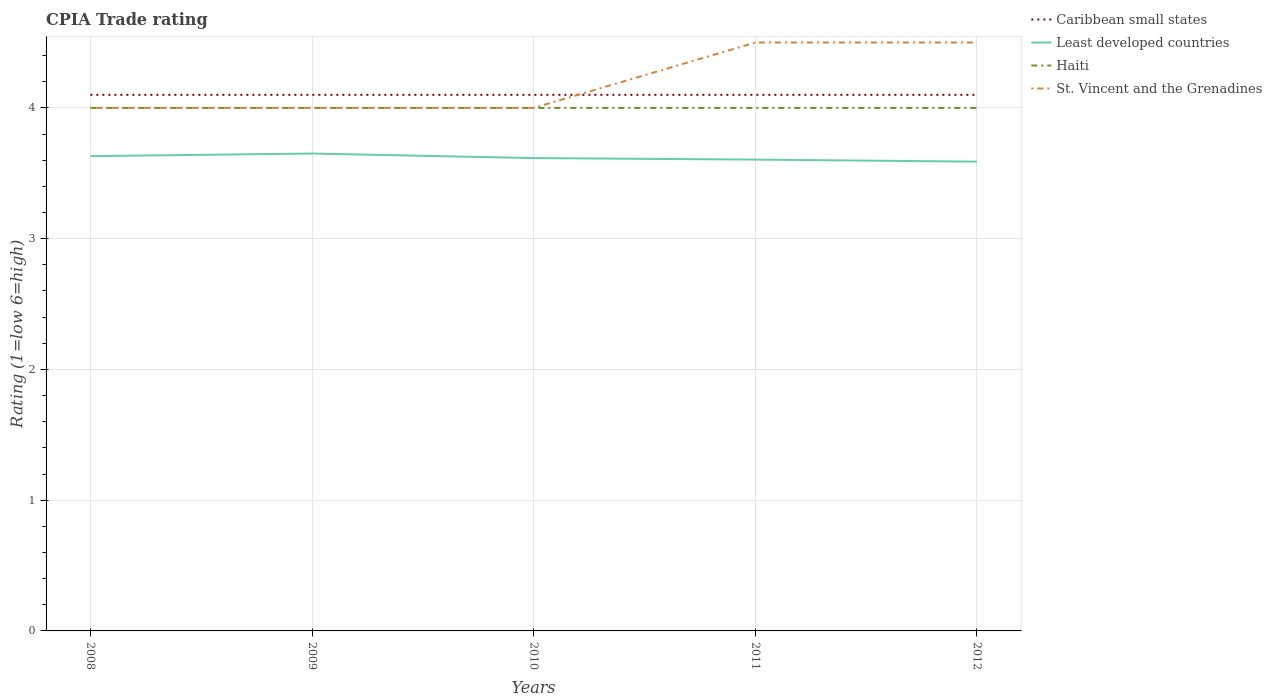How many different coloured lines are there?
Give a very brief answer. 4. Does the line corresponding to Caribbean small states intersect with the line corresponding to Haiti?
Your response must be concise. No. Is the number of lines equal to the number of legend labels?
Offer a terse response. Yes. Across all years, what is the maximum CPIA rating in St. Vincent and the Grenadines?
Offer a very short reply. 4. What is the difference between the highest and the second highest CPIA rating in Haiti?
Make the answer very short. 0. What is the difference between the highest and the lowest CPIA rating in Haiti?
Your answer should be very brief. 0. Does the graph contain any zero values?
Provide a short and direct response. No. Does the graph contain grids?
Your answer should be very brief. Yes. How many legend labels are there?
Provide a succinct answer. 4. How are the legend labels stacked?
Provide a short and direct response. Vertical. What is the title of the graph?
Make the answer very short. CPIA Trade rating. What is the label or title of the X-axis?
Provide a succinct answer. Years. What is the label or title of the Y-axis?
Give a very brief answer. Rating (1=low 6=high). What is the Rating (1=low 6=high) of Least developed countries in 2008?
Provide a succinct answer. 3.63. What is the Rating (1=low 6=high) in St. Vincent and the Grenadines in 2008?
Provide a short and direct response. 4. What is the Rating (1=low 6=high) of Caribbean small states in 2009?
Your answer should be very brief. 4.1. What is the Rating (1=low 6=high) in Least developed countries in 2009?
Give a very brief answer. 3.65. What is the Rating (1=low 6=high) in St. Vincent and the Grenadines in 2009?
Your answer should be very brief. 4. What is the Rating (1=low 6=high) in Caribbean small states in 2010?
Offer a very short reply. 4.1. What is the Rating (1=low 6=high) in Least developed countries in 2010?
Offer a very short reply. 3.62. What is the Rating (1=low 6=high) in Haiti in 2010?
Your answer should be compact. 4. What is the Rating (1=low 6=high) in St. Vincent and the Grenadines in 2010?
Your answer should be very brief. 4. What is the Rating (1=low 6=high) of Least developed countries in 2011?
Your answer should be very brief. 3.6. What is the Rating (1=low 6=high) of St. Vincent and the Grenadines in 2011?
Your response must be concise. 4.5. What is the Rating (1=low 6=high) in Caribbean small states in 2012?
Keep it short and to the point. 4.1. What is the Rating (1=low 6=high) in Least developed countries in 2012?
Keep it short and to the point. 3.59. What is the Rating (1=low 6=high) in St. Vincent and the Grenadines in 2012?
Your response must be concise. 4.5. Across all years, what is the maximum Rating (1=low 6=high) of Least developed countries?
Make the answer very short. 3.65. Across all years, what is the maximum Rating (1=low 6=high) in St. Vincent and the Grenadines?
Make the answer very short. 4.5. Across all years, what is the minimum Rating (1=low 6=high) of Least developed countries?
Ensure brevity in your answer.  3.59. What is the total Rating (1=low 6=high) in Least developed countries in the graph?
Your answer should be very brief. 18.09. What is the difference between the Rating (1=low 6=high) of Least developed countries in 2008 and that in 2009?
Give a very brief answer. -0.02. What is the difference between the Rating (1=low 6=high) in Haiti in 2008 and that in 2009?
Give a very brief answer. 0. What is the difference between the Rating (1=low 6=high) in Caribbean small states in 2008 and that in 2010?
Your response must be concise. 0. What is the difference between the Rating (1=low 6=high) of Least developed countries in 2008 and that in 2010?
Offer a very short reply. 0.01. What is the difference between the Rating (1=low 6=high) in Haiti in 2008 and that in 2010?
Offer a very short reply. 0. What is the difference between the Rating (1=low 6=high) in St. Vincent and the Grenadines in 2008 and that in 2010?
Offer a very short reply. 0. What is the difference between the Rating (1=low 6=high) in Least developed countries in 2008 and that in 2011?
Ensure brevity in your answer.  0.03. What is the difference between the Rating (1=low 6=high) of Haiti in 2008 and that in 2011?
Offer a terse response. 0. What is the difference between the Rating (1=low 6=high) of Least developed countries in 2008 and that in 2012?
Your answer should be compact. 0.04. What is the difference between the Rating (1=low 6=high) of Caribbean small states in 2009 and that in 2010?
Make the answer very short. 0. What is the difference between the Rating (1=low 6=high) in Least developed countries in 2009 and that in 2010?
Offer a terse response. 0.03. What is the difference between the Rating (1=low 6=high) in Haiti in 2009 and that in 2010?
Your answer should be compact. 0. What is the difference between the Rating (1=low 6=high) in St. Vincent and the Grenadines in 2009 and that in 2010?
Make the answer very short. 0. What is the difference between the Rating (1=low 6=high) of Least developed countries in 2009 and that in 2011?
Offer a terse response. 0.05. What is the difference between the Rating (1=low 6=high) in Least developed countries in 2009 and that in 2012?
Give a very brief answer. 0.06. What is the difference between the Rating (1=low 6=high) of Caribbean small states in 2010 and that in 2011?
Provide a succinct answer. 0. What is the difference between the Rating (1=low 6=high) in Least developed countries in 2010 and that in 2011?
Give a very brief answer. 0.01. What is the difference between the Rating (1=low 6=high) in Haiti in 2010 and that in 2011?
Your answer should be very brief. 0. What is the difference between the Rating (1=low 6=high) of Caribbean small states in 2010 and that in 2012?
Offer a terse response. 0. What is the difference between the Rating (1=low 6=high) of Least developed countries in 2010 and that in 2012?
Offer a terse response. 0.03. What is the difference between the Rating (1=low 6=high) in Haiti in 2010 and that in 2012?
Your answer should be very brief. 0. What is the difference between the Rating (1=low 6=high) in Least developed countries in 2011 and that in 2012?
Ensure brevity in your answer.  0.02. What is the difference between the Rating (1=low 6=high) of Haiti in 2011 and that in 2012?
Make the answer very short. 0. What is the difference between the Rating (1=low 6=high) of Caribbean small states in 2008 and the Rating (1=low 6=high) of Least developed countries in 2009?
Your answer should be compact. 0.45. What is the difference between the Rating (1=low 6=high) of Caribbean small states in 2008 and the Rating (1=low 6=high) of Haiti in 2009?
Give a very brief answer. 0.1. What is the difference between the Rating (1=low 6=high) of Least developed countries in 2008 and the Rating (1=low 6=high) of Haiti in 2009?
Provide a succinct answer. -0.37. What is the difference between the Rating (1=low 6=high) of Least developed countries in 2008 and the Rating (1=low 6=high) of St. Vincent and the Grenadines in 2009?
Ensure brevity in your answer.  -0.37. What is the difference between the Rating (1=low 6=high) in Haiti in 2008 and the Rating (1=low 6=high) in St. Vincent and the Grenadines in 2009?
Your response must be concise. 0. What is the difference between the Rating (1=low 6=high) of Caribbean small states in 2008 and the Rating (1=low 6=high) of Least developed countries in 2010?
Your answer should be compact. 0.48. What is the difference between the Rating (1=low 6=high) in Caribbean small states in 2008 and the Rating (1=low 6=high) in Haiti in 2010?
Make the answer very short. 0.1. What is the difference between the Rating (1=low 6=high) in Least developed countries in 2008 and the Rating (1=low 6=high) in Haiti in 2010?
Provide a short and direct response. -0.37. What is the difference between the Rating (1=low 6=high) of Least developed countries in 2008 and the Rating (1=low 6=high) of St. Vincent and the Grenadines in 2010?
Your response must be concise. -0.37. What is the difference between the Rating (1=low 6=high) in Caribbean small states in 2008 and the Rating (1=low 6=high) in Least developed countries in 2011?
Your answer should be compact. 0.5. What is the difference between the Rating (1=low 6=high) of Least developed countries in 2008 and the Rating (1=low 6=high) of Haiti in 2011?
Your answer should be compact. -0.37. What is the difference between the Rating (1=low 6=high) of Least developed countries in 2008 and the Rating (1=low 6=high) of St. Vincent and the Grenadines in 2011?
Offer a very short reply. -0.87. What is the difference between the Rating (1=low 6=high) of Caribbean small states in 2008 and the Rating (1=low 6=high) of Least developed countries in 2012?
Offer a terse response. 0.51. What is the difference between the Rating (1=low 6=high) of Caribbean small states in 2008 and the Rating (1=low 6=high) of Haiti in 2012?
Keep it short and to the point. 0.1. What is the difference between the Rating (1=low 6=high) in Caribbean small states in 2008 and the Rating (1=low 6=high) in St. Vincent and the Grenadines in 2012?
Ensure brevity in your answer.  -0.4. What is the difference between the Rating (1=low 6=high) in Least developed countries in 2008 and the Rating (1=low 6=high) in Haiti in 2012?
Your response must be concise. -0.37. What is the difference between the Rating (1=low 6=high) of Least developed countries in 2008 and the Rating (1=low 6=high) of St. Vincent and the Grenadines in 2012?
Provide a short and direct response. -0.87. What is the difference between the Rating (1=low 6=high) of Haiti in 2008 and the Rating (1=low 6=high) of St. Vincent and the Grenadines in 2012?
Give a very brief answer. -0.5. What is the difference between the Rating (1=low 6=high) of Caribbean small states in 2009 and the Rating (1=low 6=high) of Least developed countries in 2010?
Offer a very short reply. 0.48. What is the difference between the Rating (1=low 6=high) in Caribbean small states in 2009 and the Rating (1=low 6=high) in St. Vincent and the Grenadines in 2010?
Your response must be concise. 0.1. What is the difference between the Rating (1=low 6=high) in Least developed countries in 2009 and the Rating (1=low 6=high) in Haiti in 2010?
Provide a succinct answer. -0.35. What is the difference between the Rating (1=low 6=high) in Least developed countries in 2009 and the Rating (1=low 6=high) in St. Vincent and the Grenadines in 2010?
Provide a succinct answer. -0.35. What is the difference between the Rating (1=low 6=high) in Caribbean small states in 2009 and the Rating (1=low 6=high) in Least developed countries in 2011?
Make the answer very short. 0.5. What is the difference between the Rating (1=low 6=high) in Caribbean small states in 2009 and the Rating (1=low 6=high) in Haiti in 2011?
Your answer should be compact. 0.1. What is the difference between the Rating (1=low 6=high) of Least developed countries in 2009 and the Rating (1=low 6=high) of Haiti in 2011?
Provide a succinct answer. -0.35. What is the difference between the Rating (1=low 6=high) in Least developed countries in 2009 and the Rating (1=low 6=high) in St. Vincent and the Grenadines in 2011?
Offer a very short reply. -0.85. What is the difference between the Rating (1=low 6=high) of Haiti in 2009 and the Rating (1=low 6=high) of St. Vincent and the Grenadines in 2011?
Make the answer very short. -0.5. What is the difference between the Rating (1=low 6=high) of Caribbean small states in 2009 and the Rating (1=low 6=high) of Least developed countries in 2012?
Offer a terse response. 0.51. What is the difference between the Rating (1=low 6=high) in Caribbean small states in 2009 and the Rating (1=low 6=high) in Haiti in 2012?
Your answer should be compact. 0.1. What is the difference between the Rating (1=low 6=high) in Caribbean small states in 2009 and the Rating (1=low 6=high) in St. Vincent and the Grenadines in 2012?
Offer a very short reply. -0.4. What is the difference between the Rating (1=low 6=high) of Least developed countries in 2009 and the Rating (1=low 6=high) of Haiti in 2012?
Your answer should be very brief. -0.35. What is the difference between the Rating (1=low 6=high) in Least developed countries in 2009 and the Rating (1=low 6=high) in St. Vincent and the Grenadines in 2012?
Offer a terse response. -0.85. What is the difference between the Rating (1=low 6=high) of Caribbean small states in 2010 and the Rating (1=low 6=high) of Least developed countries in 2011?
Provide a short and direct response. 0.5. What is the difference between the Rating (1=low 6=high) of Caribbean small states in 2010 and the Rating (1=low 6=high) of Haiti in 2011?
Offer a very short reply. 0.1. What is the difference between the Rating (1=low 6=high) in Caribbean small states in 2010 and the Rating (1=low 6=high) in St. Vincent and the Grenadines in 2011?
Provide a short and direct response. -0.4. What is the difference between the Rating (1=low 6=high) in Least developed countries in 2010 and the Rating (1=low 6=high) in Haiti in 2011?
Provide a succinct answer. -0.38. What is the difference between the Rating (1=low 6=high) in Least developed countries in 2010 and the Rating (1=low 6=high) in St. Vincent and the Grenadines in 2011?
Provide a succinct answer. -0.88. What is the difference between the Rating (1=low 6=high) in Caribbean small states in 2010 and the Rating (1=low 6=high) in Least developed countries in 2012?
Make the answer very short. 0.51. What is the difference between the Rating (1=low 6=high) in Caribbean small states in 2010 and the Rating (1=low 6=high) in Haiti in 2012?
Provide a short and direct response. 0.1. What is the difference between the Rating (1=low 6=high) of Caribbean small states in 2010 and the Rating (1=low 6=high) of St. Vincent and the Grenadines in 2012?
Offer a terse response. -0.4. What is the difference between the Rating (1=low 6=high) of Least developed countries in 2010 and the Rating (1=low 6=high) of Haiti in 2012?
Offer a very short reply. -0.38. What is the difference between the Rating (1=low 6=high) of Least developed countries in 2010 and the Rating (1=low 6=high) of St. Vincent and the Grenadines in 2012?
Make the answer very short. -0.88. What is the difference between the Rating (1=low 6=high) in Caribbean small states in 2011 and the Rating (1=low 6=high) in Least developed countries in 2012?
Your answer should be very brief. 0.51. What is the difference between the Rating (1=low 6=high) of Caribbean small states in 2011 and the Rating (1=low 6=high) of Haiti in 2012?
Provide a succinct answer. 0.1. What is the difference between the Rating (1=low 6=high) of Least developed countries in 2011 and the Rating (1=low 6=high) of Haiti in 2012?
Provide a short and direct response. -0.4. What is the difference between the Rating (1=low 6=high) in Least developed countries in 2011 and the Rating (1=low 6=high) in St. Vincent and the Grenadines in 2012?
Provide a short and direct response. -0.9. What is the average Rating (1=low 6=high) in Least developed countries per year?
Your answer should be compact. 3.62. What is the average Rating (1=low 6=high) in Haiti per year?
Provide a succinct answer. 4. What is the average Rating (1=low 6=high) of St. Vincent and the Grenadines per year?
Keep it short and to the point. 4.2. In the year 2008, what is the difference between the Rating (1=low 6=high) of Caribbean small states and Rating (1=low 6=high) of Least developed countries?
Keep it short and to the point. 0.47. In the year 2008, what is the difference between the Rating (1=low 6=high) in Caribbean small states and Rating (1=low 6=high) in Haiti?
Ensure brevity in your answer.  0.1. In the year 2008, what is the difference between the Rating (1=low 6=high) of Caribbean small states and Rating (1=low 6=high) of St. Vincent and the Grenadines?
Provide a succinct answer. 0.1. In the year 2008, what is the difference between the Rating (1=low 6=high) of Least developed countries and Rating (1=low 6=high) of Haiti?
Your answer should be very brief. -0.37. In the year 2008, what is the difference between the Rating (1=low 6=high) in Least developed countries and Rating (1=low 6=high) in St. Vincent and the Grenadines?
Make the answer very short. -0.37. In the year 2009, what is the difference between the Rating (1=low 6=high) in Caribbean small states and Rating (1=low 6=high) in Least developed countries?
Your answer should be very brief. 0.45. In the year 2009, what is the difference between the Rating (1=low 6=high) of Caribbean small states and Rating (1=low 6=high) of Haiti?
Offer a very short reply. 0.1. In the year 2009, what is the difference between the Rating (1=low 6=high) of Least developed countries and Rating (1=low 6=high) of Haiti?
Your answer should be compact. -0.35. In the year 2009, what is the difference between the Rating (1=low 6=high) in Least developed countries and Rating (1=low 6=high) in St. Vincent and the Grenadines?
Your response must be concise. -0.35. In the year 2010, what is the difference between the Rating (1=low 6=high) of Caribbean small states and Rating (1=low 6=high) of Least developed countries?
Your response must be concise. 0.48. In the year 2010, what is the difference between the Rating (1=low 6=high) in Caribbean small states and Rating (1=low 6=high) in St. Vincent and the Grenadines?
Offer a terse response. 0.1. In the year 2010, what is the difference between the Rating (1=low 6=high) in Least developed countries and Rating (1=low 6=high) in Haiti?
Give a very brief answer. -0.38. In the year 2010, what is the difference between the Rating (1=low 6=high) of Least developed countries and Rating (1=low 6=high) of St. Vincent and the Grenadines?
Your answer should be compact. -0.38. In the year 2010, what is the difference between the Rating (1=low 6=high) in Haiti and Rating (1=low 6=high) in St. Vincent and the Grenadines?
Ensure brevity in your answer.  0. In the year 2011, what is the difference between the Rating (1=low 6=high) in Caribbean small states and Rating (1=low 6=high) in Least developed countries?
Offer a terse response. 0.5. In the year 2011, what is the difference between the Rating (1=low 6=high) of Caribbean small states and Rating (1=low 6=high) of Haiti?
Ensure brevity in your answer.  0.1. In the year 2011, what is the difference between the Rating (1=low 6=high) in Caribbean small states and Rating (1=low 6=high) in St. Vincent and the Grenadines?
Your answer should be very brief. -0.4. In the year 2011, what is the difference between the Rating (1=low 6=high) in Least developed countries and Rating (1=low 6=high) in Haiti?
Make the answer very short. -0.4. In the year 2011, what is the difference between the Rating (1=low 6=high) of Least developed countries and Rating (1=low 6=high) of St. Vincent and the Grenadines?
Provide a succinct answer. -0.9. In the year 2012, what is the difference between the Rating (1=low 6=high) in Caribbean small states and Rating (1=low 6=high) in Least developed countries?
Offer a terse response. 0.51. In the year 2012, what is the difference between the Rating (1=low 6=high) of Least developed countries and Rating (1=low 6=high) of Haiti?
Make the answer very short. -0.41. In the year 2012, what is the difference between the Rating (1=low 6=high) in Least developed countries and Rating (1=low 6=high) in St. Vincent and the Grenadines?
Keep it short and to the point. -0.91. What is the ratio of the Rating (1=low 6=high) in Caribbean small states in 2008 to that in 2009?
Make the answer very short. 1. What is the ratio of the Rating (1=low 6=high) in Least developed countries in 2008 to that in 2009?
Provide a succinct answer. 0.99. What is the ratio of the Rating (1=low 6=high) of Haiti in 2008 to that in 2009?
Your answer should be compact. 1. What is the ratio of the Rating (1=low 6=high) in St. Vincent and the Grenadines in 2008 to that in 2009?
Your answer should be compact. 1. What is the ratio of the Rating (1=low 6=high) in Caribbean small states in 2008 to that in 2010?
Offer a very short reply. 1. What is the ratio of the Rating (1=low 6=high) of Caribbean small states in 2008 to that in 2011?
Your answer should be very brief. 1. What is the ratio of the Rating (1=low 6=high) in Least developed countries in 2008 to that in 2011?
Offer a very short reply. 1.01. What is the ratio of the Rating (1=low 6=high) of St. Vincent and the Grenadines in 2008 to that in 2011?
Your response must be concise. 0.89. What is the ratio of the Rating (1=low 6=high) in Least developed countries in 2008 to that in 2012?
Ensure brevity in your answer.  1.01. What is the ratio of the Rating (1=low 6=high) of Haiti in 2008 to that in 2012?
Your response must be concise. 1. What is the ratio of the Rating (1=low 6=high) of Least developed countries in 2009 to that in 2010?
Offer a terse response. 1.01. What is the ratio of the Rating (1=low 6=high) of St. Vincent and the Grenadines in 2009 to that in 2010?
Your answer should be compact. 1. What is the ratio of the Rating (1=low 6=high) in Caribbean small states in 2009 to that in 2011?
Make the answer very short. 1. What is the ratio of the Rating (1=low 6=high) of Least developed countries in 2009 to that in 2011?
Your answer should be very brief. 1.01. What is the ratio of the Rating (1=low 6=high) of Caribbean small states in 2009 to that in 2012?
Your response must be concise. 1. What is the ratio of the Rating (1=low 6=high) in Least developed countries in 2009 to that in 2012?
Provide a succinct answer. 1.02. What is the ratio of the Rating (1=low 6=high) of Haiti in 2009 to that in 2012?
Your response must be concise. 1. What is the ratio of the Rating (1=low 6=high) of St. Vincent and the Grenadines in 2009 to that in 2012?
Ensure brevity in your answer.  0.89. What is the ratio of the Rating (1=low 6=high) of Least developed countries in 2010 to that in 2012?
Your answer should be very brief. 1.01. What is the ratio of the Rating (1=low 6=high) in St. Vincent and the Grenadines in 2010 to that in 2012?
Give a very brief answer. 0.89. What is the ratio of the Rating (1=low 6=high) in Least developed countries in 2011 to that in 2012?
Your answer should be compact. 1. What is the ratio of the Rating (1=low 6=high) in Haiti in 2011 to that in 2012?
Make the answer very short. 1. What is the difference between the highest and the second highest Rating (1=low 6=high) of Caribbean small states?
Make the answer very short. 0. What is the difference between the highest and the second highest Rating (1=low 6=high) of Least developed countries?
Offer a terse response. 0.02. What is the difference between the highest and the second highest Rating (1=low 6=high) in Haiti?
Your answer should be compact. 0. What is the difference between the highest and the second highest Rating (1=low 6=high) in St. Vincent and the Grenadines?
Your answer should be compact. 0. What is the difference between the highest and the lowest Rating (1=low 6=high) of Caribbean small states?
Provide a short and direct response. 0. What is the difference between the highest and the lowest Rating (1=low 6=high) of Least developed countries?
Offer a terse response. 0.06. What is the difference between the highest and the lowest Rating (1=low 6=high) of Haiti?
Provide a short and direct response. 0. What is the difference between the highest and the lowest Rating (1=low 6=high) of St. Vincent and the Grenadines?
Your answer should be compact. 0.5. 